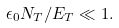Convert formula to latex. <formula><loc_0><loc_0><loc_500><loc_500>\epsilon _ { 0 } N _ { T } / E _ { T } \ll 1 .</formula> 